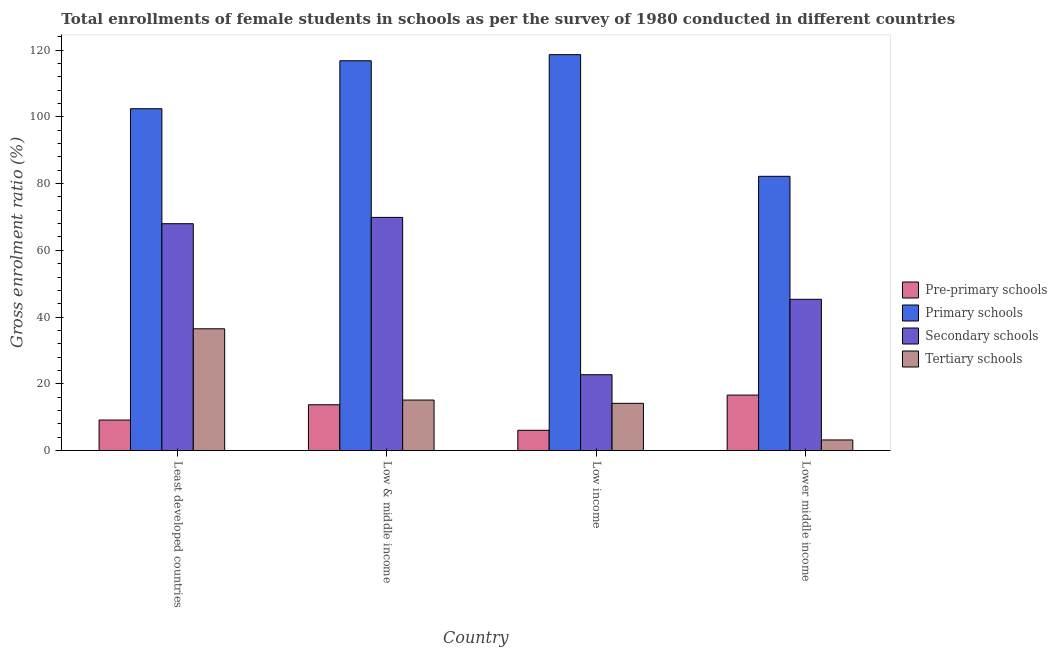How many different coloured bars are there?
Provide a short and direct response. 4. How many groups of bars are there?
Provide a succinct answer. 4. Are the number of bars per tick equal to the number of legend labels?
Provide a succinct answer. Yes. How many bars are there on the 1st tick from the left?
Offer a terse response. 4. What is the label of the 4th group of bars from the left?
Provide a short and direct response. Lower middle income. In how many cases, is the number of bars for a given country not equal to the number of legend labels?
Make the answer very short. 0. What is the gross enrolment ratio(female) in pre-primary schools in Least developed countries?
Offer a terse response. 9.13. Across all countries, what is the maximum gross enrolment ratio(female) in primary schools?
Your response must be concise. 118.65. Across all countries, what is the minimum gross enrolment ratio(female) in tertiary schools?
Your response must be concise. 3.16. What is the total gross enrolment ratio(female) in primary schools in the graph?
Give a very brief answer. 420.09. What is the difference between the gross enrolment ratio(female) in pre-primary schools in Low & middle income and that in Low income?
Make the answer very short. 7.65. What is the difference between the gross enrolment ratio(female) in secondary schools in Low & middle income and the gross enrolment ratio(female) in tertiary schools in Least developed countries?
Make the answer very short. 33.39. What is the average gross enrolment ratio(female) in pre-primary schools per country?
Your answer should be compact. 11.37. What is the difference between the gross enrolment ratio(female) in pre-primary schools and gross enrolment ratio(female) in primary schools in Least developed countries?
Provide a succinct answer. -93.31. What is the ratio of the gross enrolment ratio(female) in tertiary schools in Low income to that in Lower middle income?
Offer a very short reply. 4.47. Is the gross enrolment ratio(female) in pre-primary schools in Least developed countries less than that in Lower middle income?
Offer a terse response. Yes. Is the difference between the gross enrolment ratio(female) in secondary schools in Least developed countries and Low income greater than the difference between the gross enrolment ratio(female) in primary schools in Least developed countries and Low income?
Offer a very short reply. Yes. What is the difference between the highest and the second highest gross enrolment ratio(female) in tertiary schools?
Ensure brevity in your answer.  21.36. What is the difference between the highest and the lowest gross enrolment ratio(female) in pre-primary schools?
Your response must be concise. 10.55. What does the 3rd bar from the left in Lower middle income represents?
Provide a succinct answer. Secondary schools. What does the 1st bar from the right in Low & middle income represents?
Provide a short and direct response. Tertiary schools. Is it the case that in every country, the sum of the gross enrolment ratio(female) in pre-primary schools and gross enrolment ratio(female) in primary schools is greater than the gross enrolment ratio(female) in secondary schools?
Offer a very short reply. Yes. How many bars are there?
Provide a succinct answer. 16. Does the graph contain grids?
Offer a terse response. No. What is the title of the graph?
Give a very brief answer. Total enrollments of female students in schools as per the survey of 1980 conducted in different countries. What is the label or title of the X-axis?
Offer a terse response. Country. What is the label or title of the Y-axis?
Make the answer very short. Gross enrolment ratio (%). What is the Gross enrolment ratio (%) in Pre-primary schools in Least developed countries?
Give a very brief answer. 9.13. What is the Gross enrolment ratio (%) in Primary schools in Least developed countries?
Provide a short and direct response. 102.44. What is the Gross enrolment ratio (%) of Secondary schools in Least developed countries?
Give a very brief answer. 67.98. What is the Gross enrolment ratio (%) of Tertiary schools in Least developed countries?
Make the answer very short. 36.48. What is the Gross enrolment ratio (%) in Pre-primary schools in Low & middle income?
Provide a short and direct response. 13.7. What is the Gross enrolment ratio (%) in Primary schools in Low & middle income?
Make the answer very short. 116.82. What is the Gross enrolment ratio (%) of Secondary schools in Low & middle income?
Give a very brief answer. 69.87. What is the Gross enrolment ratio (%) of Tertiary schools in Low & middle income?
Ensure brevity in your answer.  15.12. What is the Gross enrolment ratio (%) in Pre-primary schools in Low income?
Your answer should be compact. 6.05. What is the Gross enrolment ratio (%) of Primary schools in Low income?
Your response must be concise. 118.65. What is the Gross enrolment ratio (%) of Secondary schools in Low income?
Offer a very short reply. 22.71. What is the Gross enrolment ratio (%) of Tertiary schools in Low income?
Offer a very short reply. 14.13. What is the Gross enrolment ratio (%) in Pre-primary schools in Lower middle income?
Make the answer very short. 16.6. What is the Gross enrolment ratio (%) in Primary schools in Lower middle income?
Offer a very short reply. 82.18. What is the Gross enrolment ratio (%) of Secondary schools in Lower middle income?
Your answer should be compact. 45.32. What is the Gross enrolment ratio (%) in Tertiary schools in Lower middle income?
Your answer should be compact. 3.16. Across all countries, what is the maximum Gross enrolment ratio (%) in Pre-primary schools?
Keep it short and to the point. 16.6. Across all countries, what is the maximum Gross enrolment ratio (%) in Primary schools?
Provide a short and direct response. 118.65. Across all countries, what is the maximum Gross enrolment ratio (%) in Secondary schools?
Your answer should be very brief. 69.87. Across all countries, what is the maximum Gross enrolment ratio (%) of Tertiary schools?
Provide a short and direct response. 36.48. Across all countries, what is the minimum Gross enrolment ratio (%) of Pre-primary schools?
Your response must be concise. 6.05. Across all countries, what is the minimum Gross enrolment ratio (%) of Primary schools?
Keep it short and to the point. 82.18. Across all countries, what is the minimum Gross enrolment ratio (%) of Secondary schools?
Your answer should be very brief. 22.71. Across all countries, what is the minimum Gross enrolment ratio (%) of Tertiary schools?
Your answer should be compact. 3.16. What is the total Gross enrolment ratio (%) of Pre-primary schools in the graph?
Provide a succinct answer. 45.49. What is the total Gross enrolment ratio (%) of Primary schools in the graph?
Keep it short and to the point. 420.09. What is the total Gross enrolment ratio (%) of Secondary schools in the graph?
Offer a very short reply. 205.87. What is the total Gross enrolment ratio (%) of Tertiary schools in the graph?
Offer a very short reply. 68.89. What is the difference between the Gross enrolment ratio (%) in Pre-primary schools in Least developed countries and that in Low & middle income?
Your answer should be very brief. -4.58. What is the difference between the Gross enrolment ratio (%) in Primary schools in Least developed countries and that in Low & middle income?
Provide a succinct answer. -14.38. What is the difference between the Gross enrolment ratio (%) in Secondary schools in Least developed countries and that in Low & middle income?
Give a very brief answer. -1.89. What is the difference between the Gross enrolment ratio (%) in Tertiary schools in Least developed countries and that in Low & middle income?
Offer a very short reply. 21.36. What is the difference between the Gross enrolment ratio (%) of Pre-primary schools in Least developed countries and that in Low income?
Offer a terse response. 3.07. What is the difference between the Gross enrolment ratio (%) of Primary schools in Least developed countries and that in Low income?
Give a very brief answer. -16.21. What is the difference between the Gross enrolment ratio (%) of Secondary schools in Least developed countries and that in Low income?
Your answer should be very brief. 45.27. What is the difference between the Gross enrolment ratio (%) of Tertiary schools in Least developed countries and that in Low income?
Offer a terse response. 22.34. What is the difference between the Gross enrolment ratio (%) in Pre-primary schools in Least developed countries and that in Lower middle income?
Your response must be concise. -7.48. What is the difference between the Gross enrolment ratio (%) in Primary schools in Least developed countries and that in Lower middle income?
Offer a very short reply. 20.26. What is the difference between the Gross enrolment ratio (%) of Secondary schools in Least developed countries and that in Lower middle income?
Your response must be concise. 22.66. What is the difference between the Gross enrolment ratio (%) of Tertiary schools in Least developed countries and that in Lower middle income?
Give a very brief answer. 33.32. What is the difference between the Gross enrolment ratio (%) in Pre-primary schools in Low & middle income and that in Low income?
Make the answer very short. 7.65. What is the difference between the Gross enrolment ratio (%) in Primary schools in Low & middle income and that in Low income?
Your answer should be compact. -1.83. What is the difference between the Gross enrolment ratio (%) in Secondary schools in Low & middle income and that in Low income?
Your answer should be compact. 47.16. What is the difference between the Gross enrolment ratio (%) of Tertiary schools in Low & middle income and that in Low income?
Ensure brevity in your answer.  0.98. What is the difference between the Gross enrolment ratio (%) in Primary schools in Low & middle income and that in Lower middle income?
Your answer should be very brief. 34.64. What is the difference between the Gross enrolment ratio (%) of Secondary schools in Low & middle income and that in Lower middle income?
Offer a very short reply. 24.55. What is the difference between the Gross enrolment ratio (%) of Tertiary schools in Low & middle income and that in Lower middle income?
Provide a short and direct response. 11.96. What is the difference between the Gross enrolment ratio (%) of Pre-primary schools in Low income and that in Lower middle income?
Give a very brief answer. -10.55. What is the difference between the Gross enrolment ratio (%) of Primary schools in Low income and that in Lower middle income?
Your answer should be compact. 36.47. What is the difference between the Gross enrolment ratio (%) of Secondary schools in Low income and that in Lower middle income?
Keep it short and to the point. -22.61. What is the difference between the Gross enrolment ratio (%) of Tertiary schools in Low income and that in Lower middle income?
Provide a succinct answer. 10.97. What is the difference between the Gross enrolment ratio (%) of Pre-primary schools in Least developed countries and the Gross enrolment ratio (%) of Primary schools in Low & middle income?
Offer a terse response. -107.69. What is the difference between the Gross enrolment ratio (%) in Pre-primary schools in Least developed countries and the Gross enrolment ratio (%) in Secondary schools in Low & middle income?
Offer a terse response. -60.74. What is the difference between the Gross enrolment ratio (%) of Pre-primary schools in Least developed countries and the Gross enrolment ratio (%) of Tertiary schools in Low & middle income?
Provide a short and direct response. -5.99. What is the difference between the Gross enrolment ratio (%) in Primary schools in Least developed countries and the Gross enrolment ratio (%) in Secondary schools in Low & middle income?
Make the answer very short. 32.57. What is the difference between the Gross enrolment ratio (%) in Primary schools in Least developed countries and the Gross enrolment ratio (%) in Tertiary schools in Low & middle income?
Give a very brief answer. 87.32. What is the difference between the Gross enrolment ratio (%) in Secondary schools in Least developed countries and the Gross enrolment ratio (%) in Tertiary schools in Low & middle income?
Provide a short and direct response. 52.86. What is the difference between the Gross enrolment ratio (%) of Pre-primary schools in Least developed countries and the Gross enrolment ratio (%) of Primary schools in Low income?
Offer a very short reply. -109.52. What is the difference between the Gross enrolment ratio (%) of Pre-primary schools in Least developed countries and the Gross enrolment ratio (%) of Secondary schools in Low income?
Make the answer very short. -13.58. What is the difference between the Gross enrolment ratio (%) of Pre-primary schools in Least developed countries and the Gross enrolment ratio (%) of Tertiary schools in Low income?
Offer a very short reply. -5.01. What is the difference between the Gross enrolment ratio (%) of Primary schools in Least developed countries and the Gross enrolment ratio (%) of Secondary schools in Low income?
Your answer should be compact. 79.73. What is the difference between the Gross enrolment ratio (%) in Primary schools in Least developed countries and the Gross enrolment ratio (%) in Tertiary schools in Low income?
Ensure brevity in your answer.  88.31. What is the difference between the Gross enrolment ratio (%) of Secondary schools in Least developed countries and the Gross enrolment ratio (%) of Tertiary schools in Low income?
Provide a short and direct response. 53.84. What is the difference between the Gross enrolment ratio (%) of Pre-primary schools in Least developed countries and the Gross enrolment ratio (%) of Primary schools in Lower middle income?
Your response must be concise. -73.05. What is the difference between the Gross enrolment ratio (%) in Pre-primary schools in Least developed countries and the Gross enrolment ratio (%) in Secondary schools in Lower middle income?
Your answer should be compact. -36.19. What is the difference between the Gross enrolment ratio (%) of Pre-primary schools in Least developed countries and the Gross enrolment ratio (%) of Tertiary schools in Lower middle income?
Ensure brevity in your answer.  5.97. What is the difference between the Gross enrolment ratio (%) of Primary schools in Least developed countries and the Gross enrolment ratio (%) of Secondary schools in Lower middle income?
Your answer should be very brief. 57.12. What is the difference between the Gross enrolment ratio (%) in Primary schools in Least developed countries and the Gross enrolment ratio (%) in Tertiary schools in Lower middle income?
Give a very brief answer. 99.28. What is the difference between the Gross enrolment ratio (%) in Secondary schools in Least developed countries and the Gross enrolment ratio (%) in Tertiary schools in Lower middle income?
Offer a very short reply. 64.81. What is the difference between the Gross enrolment ratio (%) of Pre-primary schools in Low & middle income and the Gross enrolment ratio (%) of Primary schools in Low income?
Provide a short and direct response. -104.94. What is the difference between the Gross enrolment ratio (%) of Pre-primary schools in Low & middle income and the Gross enrolment ratio (%) of Secondary schools in Low income?
Provide a short and direct response. -9. What is the difference between the Gross enrolment ratio (%) in Pre-primary schools in Low & middle income and the Gross enrolment ratio (%) in Tertiary schools in Low income?
Ensure brevity in your answer.  -0.43. What is the difference between the Gross enrolment ratio (%) of Primary schools in Low & middle income and the Gross enrolment ratio (%) of Secondary schools in Low income?
Give a very brief answer. 94.11. What is the difference between the Gross enrolment ratio (%) of Primary schools in Low & middle income and the Gross enrolment ratio (%) of Tertiary schools in Low income?
Your answer should be compact. 102.69. What is the difference between the Gross enrolment ratio (%) of Secondary schools in Low & middle income and the Gross enrolment ratio (%) of Tertiary schools in Low income?
Keep it short and to the point. 55.73. What is the difference between the Gross enrolment ratio (%) in Pre-primary schools in Low & middle income and the Gross enrolment ratio (%) in Primary schools in Lower middle income?
Keep it short and to the point. -68.48. What is the difference between the Gross enrolment ratio (%) in Pre-primary schools in Low & middle income and the Gross enrolment ratio (%) in Secondary schools in Lower middle income?
Keep it short and to the point. -31.62. What is the difference between the Gross enrolment ratio (%) of Pre-primary schools in Low & middle income and the Gross enrolment ratio (%) of Tertiary schools in Lower middle income?
Ensure brevity in your answer.  10.54. What is the difference between the Gross enrolment ratio (%) of Primary schools in Low & middle income and the Gross enrolment ratio (%) of Secondary schools in Lower middle income?
Provide a short and direct response. 71.5. What is the difference between the Gross enrolment ratio (%) in Primary schools in Low & middle income and the Gross enrolment ratio (%) in Tertiary schools in Lower middle income?
Provide a short and direct response. 113.66. What is the difference between the Gross enrolment ratio (%) of Secondary schools in Low & middle income and the Gross enrolment ratio (%) of Tertiary schools in Lower middle income?
Provide a succinct answer. 66.71. What is the difference between the Gross enrolment ratio (%) in Pre-primary schools in Low income and the Gross enrolment ratio (%) in Primary schools in Lower middle income?
Offer a terse response. -76.13. What is the difference between the Gross enrolment ratio (%) in Pre-primary schools in Low income and the Gross enrolment ratio (%) in Secondary schools in Lower middle income?
Offer a very short reply. -39.27. What is the difference between the Gross enrolment ratio (%) of Pre-primary schools in Low income and the Gross enrolment ratio (%) of Tertiary schools in Lower middle income?
Offer a terse response. 2.89. What is the difference between the Gross enrolment ratio (%) in Primary schools in Low income and the Gross enrolment ratio (%) in Secondary schools in Lower middle income?
Make the answer very short. 73.33. What is the difference between the Gross enrolment ratio (%) in Primary schools in Low income and the Gross enrolment ratio (%) in Tertiary schools in Lower middle income?
Provide a succinct answer. 115.49. What is the difference between the Gross enrolment ratio (%) in Secondary schools in Low income and the Gross enrolment ratio (%) in Tertiary schools in Lower middle income?
Keep it short and to the point. 19.55. What is the average Gross enrolment ratio (%) in Pre-primary schools per country?
Provide a short and direct response. 11.37. What is the average Gross enrolment ratio (%) of Primary schools per country?
Your response must be concise. 105.02. What is the average Gross enrolment ratio (%) of Secondary schools per country?
Provide a short and direct response. 51.47. What is the average Gross enrolment ratio (%) in Tertiary schools per country?
Give a very brief answer. 17.22. What is the difference between the Gross enrolment ratio (%) of Pre-primary schools and Gross enrolment ratio (%) of Primary schools in Least developed countries?
Make the answer very short. -93.31. What is the difference between the Gross enrolment ratio (%) of Pre-primary schools and Gross enrolment ratio (%) of Secondary schools in Least developed countries?
Provide a short and direct response. -58.85. What is the difference between the Gross enrolment ratio (%) in Pre-primary schools and Gross enrolment ratio (%) in Tertiary schools in Least developed countries?
Your answer should be very brief. -27.35. What is the difference between the Gross enrolment ratio (%) of Primary schools and Gross enrolment ratio (%) of Secondary schools in Least developed countries?
Your response must be concise. 34.47. What is the difference between the Gross enrolment ratio (%) in Primary schools and Gross enrolment ratio (%) in Tertiary schools in Least developed countries?
Offer a very short reply. 65.96. What is the difference between the Gross enrolment ratio (%) of Secondary schools and Gross enrolment ratio (%) of Tertiary schools in Least developed countries?
Keep it short and to the point. 31.5. What is the difference between the Gross enrolment ratio (%) in Pre-primary schools and Gross enrolment ratio (%) in Primary schools in Low & middle income?
Give a very brief answer. -103.12. What is the difference between the Gross enrolment ratio (%) of Pre-primary schools and Gross enrolment ratio (%) of Secondary schools in Low & middle income?
Make the answer very short. -56.16. What is the difference between the Gross enrolment ratio (%) in Pre-primary schools and Gross enrolment ratio (%) in Tertiary schools in Low & middle income?
Offer a terse response. -1.41. What is the difference between the Gross enrolment ratio (%) of Primary schools and Gross enrolment ratio (%) of Secondary schools in Low & middle income?
Keep it short and to the point. 46.95. What is the difference between the Gross enrolment ratio (%) in Primary schools and Gross enrolment ratio (%) in Tertiary schools in Low & middle income?
Your response must be concise. 101.7. What is the difference between the Gross enrolment ratio (%) in Secondary schools and Gross enrolment ratio (%) in Tertiary schools in Low & middle income?
Make the answer very short. 54.75. What is the difference between the Gross enrolment ratio (%) of Pre-primary schools and Gross enrolment ratio (%) of Primary schools in Low income?
Your answer should be very brief. -112.59. What is the difference between the Gross enrolment ratio (%) in Pre-primary schools and Gross enrolment ratio (%) in Secondary schools in Low income?
Offer a terse response. -16.65. What is the difference between the Gross enrolment ratio (%) of Pre-primary schools and Gross enrolment ratio (%) of Tertiary schools in Low income?
Give a very brief answer. -8.08. What is the difference between the Gross enrolment ratio (%) in Primary schools and Gross enrolment ratio (%) in Secondary schools in Low income?
Provide a succinct answer. 95.94. What is the difference between the Gross enrolment ratio (%) of Primary schools and Gross enrolment ratio (%) of Tertiary schools in Low income?
Offer a terse response. 104.51. What is the difference between the Gross enrolment ratio (%) of Secondary schools and Gross enrolment ratio (%) of Tertiary schools in Low income?
Provide a short and direct response. 8.57. What is the difference between the Gross enrolment ratio (%) in Pre-primary schools and Gross enrolment ratio (%) in Primary schools in Lower middle income?
Make the answer very short. -65.58. What is the difference between the Gross enrolment ratio (%) in Pre-primary schools and Gross enrolment ratio (%) in Secondary schools in Lower middle income?
Make the answer very short. -28.72. What is the difference between the Gross enrolment ratio (%) in Pre-primary schools and Gross enrolment ratio (%) in Tertiary schools in Lower middle income?
Ensure brevity in your answer.  13.44. What is the difference between the Gross enrolment ratio (%) in Primary schools and Gross enrolment ratio (%) in Secondary schools in Lower middle income?
Your response must be concise. 36.86. What is the difference between the Gross enrolment ratio (%) of Primary schools and Gross enrolment ratio (%) of Tertiary schools in Lower middle income?
Offer a very short reply. 79.02. What is the difference between the Gross enrolment ratio (%) in Secondary schools and Gross enrolment ratio (%) in Tertiary schools in Lower middle income?
Ensure brevity in your answer.  42.16. What is the ratio of the Gross enrolment ratio (%) of Pre-primary schools in Least developed countries to that in Low & middle income?
Ensure brevity in your answer.  0.67. What is the ratio of the Gross enrolment ratio (%) of Primary schools in Least developed countries to that in Low & middle income?
Your answer should be very brief. 0.88. What is the ratio of the Gross enrolment ratio (%) in Secondary schools in Least developed countries to that in Low & middle income?
Make the answer very short. 0.97. What is the ratio of the Gross enrolment ratio (%) of Tertiary schools in Least developed countries to that in Low & middle income?
Your answer should be very brief. 2.41. What is the ratio of the Gross enrolment ratio (%) in Pre-primary schools in Least developed countries to that in Low income?
Your answer should be compact. 1.51. What is the ratio of the Gross enrolment ratio (%) of Primary schools in Least developed countries to that in Low income?
Your answer should be compact. 0.86. What is the ratio of the Gross enrolment ratio (%) of Secondary schools in Least developed countries to that in Low income?
Offer a terse response. 2.99. What is the ratio of the Gross enrolment ratio (%) of Tertiary schools in Least developed countries to that in Low income?
Offer a very short reply. 2.58. What is the ratio of the Gross enrolment ratio (%) of Pre-primary schools in Least developed countries to that in Lower middle income?
Offer a very short reply. 0.55. What is the ratio of the Gross enrolment ratio (%) of Primary schools in Least developed countries to that in Lower middle income?
Keep it short and to the point. 1.25. What is the ratio of the Gross enrolment ratio (%) in Secondary schools in Least developed countries to that in Lower middle income?
Offer a very short reply. 1.5. What is the ratio of the Gross enrolment ratio (%) of Tertiary schools in Least developed countries to that in Lower middle income?
Make the answer very short. 11.54. What is the ratio of the Gross enrolment ratio (%) in Pre-primary schools in Low & middle income to that in Low income?
Offer a terse response. 2.26. What is the ratio of the Gross enrolment ratio (%) in Primary schools in Low & middle income to that in Low income?
Offer a very short reply. 0.98. What is the ratio of the Gross enrolment ratio (%) in Secondary schools in Low & middle income to that in Low income?
Your response must be concise. 3.08. What is the ratio of the Gross enrolment ratio (%) of Tertiary schools in Low & middle income to that in Low income?
Your response must be concise. 1.07. What is the ratio of the Gross enrolment ratio (%) of Pre-primary schools in Low & middle income to that in Lower middle income?
Offer a very short reply. 0.83. What is the ratio of the Gross enrolment ratio (%) in Primary schools in Low & middle income to that in Lower middle income?
Provide a short and direct response. 1.42. What is the ratio of the Gross enrolment ratio (%) in Secondary schools in Low & middle income to that in Lower middle income?
Your response must be concise. 1.54. What is the ratio of the Gross enrolment ratio (%) of Tertiary schools in Low & middle income to that in Lower middle income?
Your response must be concise. 4.78. What is the ratio of the Gross enrolment ratio (%) in Pre-primary schools in Low income to that in Lower middle income?
Offer a terse response. 0.36. What is the ratio of the Gross enrolment ratio (%) of Primary schools in Low income to that in Lower middle income?
Your answer should be compact. 1.44. What is the ratio of the Gross enrolment ratio (%) of Secondary schools in Low income to that in Lower middle income?
Provide a short and direct response. 0.5. What is the ratio of the Gross enrolment ratio (%) in Tertiary schools in Low income to that in Lower middle income?
Provide a succinct answer. 4.47. What is the difference between the highest and the second highest Gross enrolment ratio (%) of Primary schools?
Offer a very short reply. 1.83. What is the difference between the highest and the second highest Gross enrolment ratio (%) in Secondary schools?
Your answer should be very brief. 1.89. What is the difference between the highest and the second highest Gross enrolment ratio (%) in Tertiary schools?
Give a very brief answer. 21.36. What is the difference between the highest and the lowest Gross enrolment ratio (%) in Pre-primary schools?
Your response must be concise. 10.55. What is the difference between the highest and the lowest Gross enrolment ratio (%) of Primary schools?
Your answer should be compact. 36.47. What is the difference between the highest and the lowest Gross enrolment ratio (%) in Secondary schools?
Give a very brief answer. 47.16. What is the difference between the highest and the lowest Gross enrolment ratio (%) in Tertiary schools?
Ensure brevity in your answer.  33.32. 